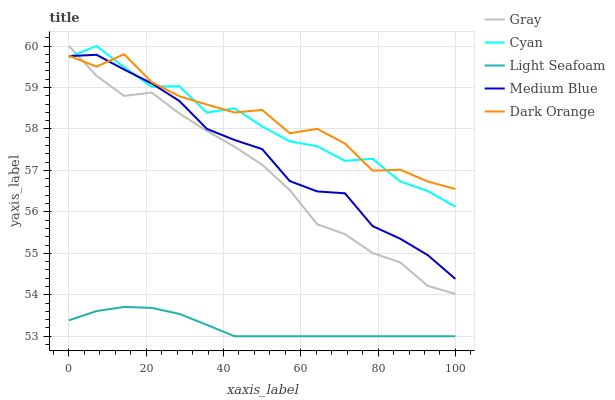Does Light Seafoam have the minimum area under the curve?
Answer yes or no. Yes. Does Dark Orange have the maximum area under the curve?
Answer yes or no. Yes. Does Gray have the minimum area under the curve?
Answer yes or no. No. Does Gray have the maximum area under the curve?
Answer yes or no. No. Is Light Seafoam the smoothest?
Answer yes or no. Yes. Is Dark Orange the roughest?
Answer yes or no. Yes. Is Gray the smoothest?
Answer yes or no. No. Is Gray the roughest?
Answer yes or no. No. Does Light Seafoam have the lowest value?
Answer yes or no. Yes. Does Gray have the lowest value?
Answer yes or no. No. Does Cyan have the highest value?
Answer yes or no. Yes. Does Light Seafoam have the highest value?
Answer yes or no. No. Is Light Seafoam less than Medium Blue?
Answer yes or no. Yes. Is Medium Blue greater than Light Seafoam?
Answer yes or no. Yes. Does Medium Blue intersect Gray?
Answer yes or no. Yes. Is Medium Blue less than Gray?
Answer yes or no. No. Is Medium Blue greater than Gray?
Answer yes or no. No. Does Light Seafoam intersect Medium Blue?
Answer yes or no. No. 